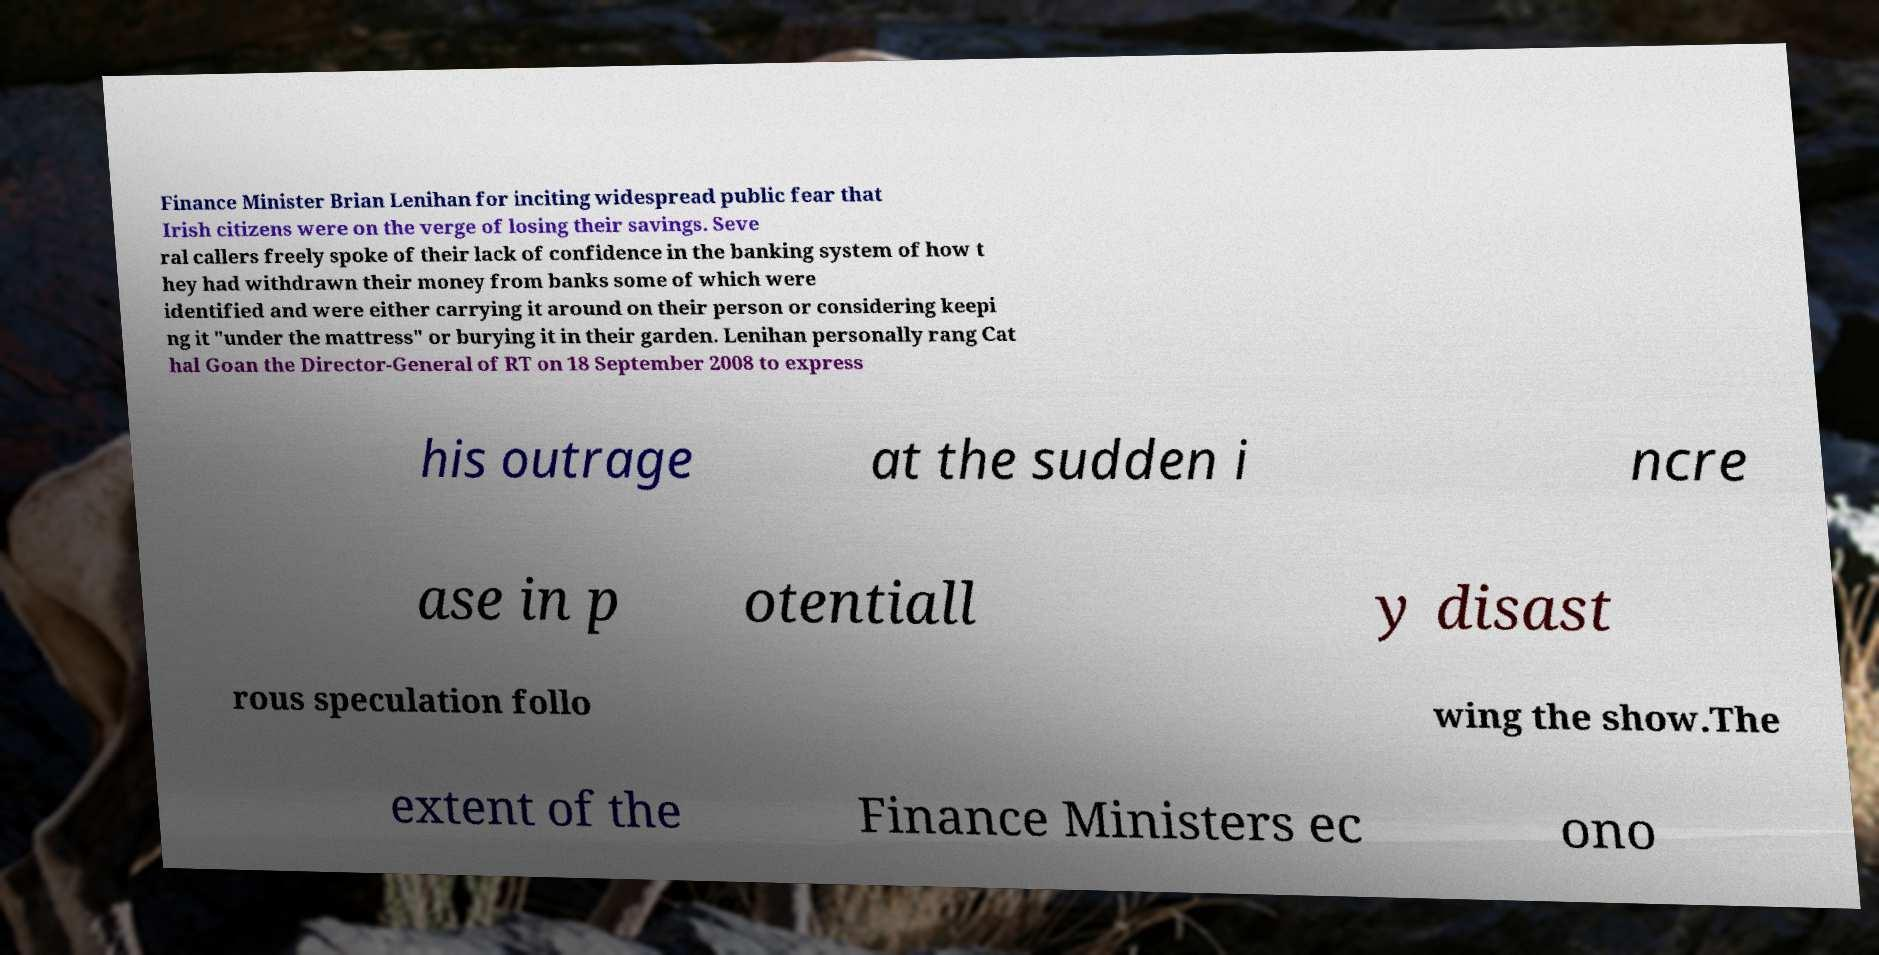Please read and relay the text visible in this image. What does it say? Finance Minister Brian Lenihan for inciting widespread public fear that Irish citizens were on the verge of losing their savings. Seve ral callers freely spoke of their lack of confidence in the banking system of how t hey had withdrawn their money from banks some of which were identified and were either carrying it around on their person or considering keepi ng it "under the mattress" or burying it in their garden. Lenihan personally rang Cat hal Goan the Director-General of RT on 18 September 2008 to express his outrage at the sudden i ncre ase in p otentiall y disast rous speculation follo wing the show.The extent of the Finance Ministers ec ono 